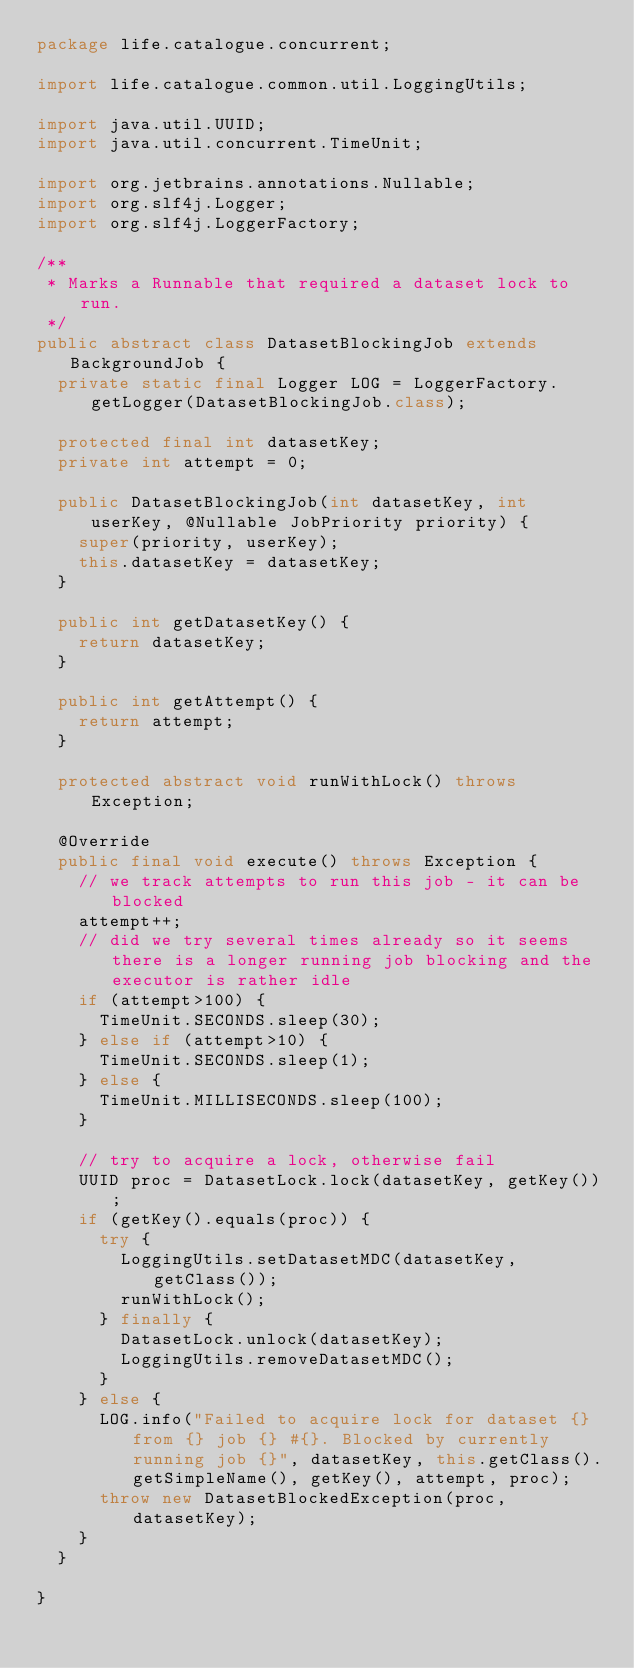<code> <loc_0><loc_0><loc_500><loc_500><_Java_>package life.catalogue.concurrent;

import life.catalogue.common.util.LoggingUtils;

import java.util.UUID;
import java.util.concurrent.TimeUnit;

import org.jetbrains.annotations.Nullable;
import org.slf4j.Logger;
import org.slf4j.LoggerFactory;

/**
 * Marks a Runnable that required a dataset lock to run.
 */
public abstract class DatasetBlockingJob extends BackgroundJob {
  private static final Logger LOG = LoggerFactory.getLogger(DatasetBlockingJob.class);

  protected final int datasetKey;
  private int attempt = 0;

  public DatasetBlockingJob(int datasetKey, int userKey, @Nullable JobPriority priority) {
    super(priority, userKey);
    this.datasetKey = datasetKey;
  }

  public int getDatasetKey() {
    return datasetKey;
  }

  public int getAttempt() {
    return attempt;
  }

  protected abstract void runWithLock() throws Exception;

  @Override
  public final void execute() throws Exception {
    // we track attempts to run this job - it can be blocked
    attempt++;
    // did we try several times already so it seems there is a longer running job blocking and the executor is rather idle
    if (attempt>100) {
      TimeUnit.SECONDS.sleep(30);
    } else if (attempt>10) {
      TimeUnit.SECONDS.sleep(1);
    } else {
      TimeUnit.MILLISECONDS.sleep(100);
    }

    // try to acquire a lock, otherwise fail
    UUID proc = DatasetLock.lock(datasetKey, getKey());
    if (getKey().equals(proc)) {
      try {
        LoggingUtils.setDatasetMDC(datasetKey, getClass());
        runWithLock();
      } finally {
        DatasetLock.unlock(datasetKey);
        LoggingUtils.removeDatasetMDC();
      }
    } else {
      LOG.info("Failed to acquire lock for dataset {} from {} job {} #{}. Blocked by currently running job {}", datasetKey, this.getClass().getSimpleName(), getKey(), attempt, proc);
      throw new DatasetBlockedException(proc, datasetKey);
    }
  }

}
</code> 